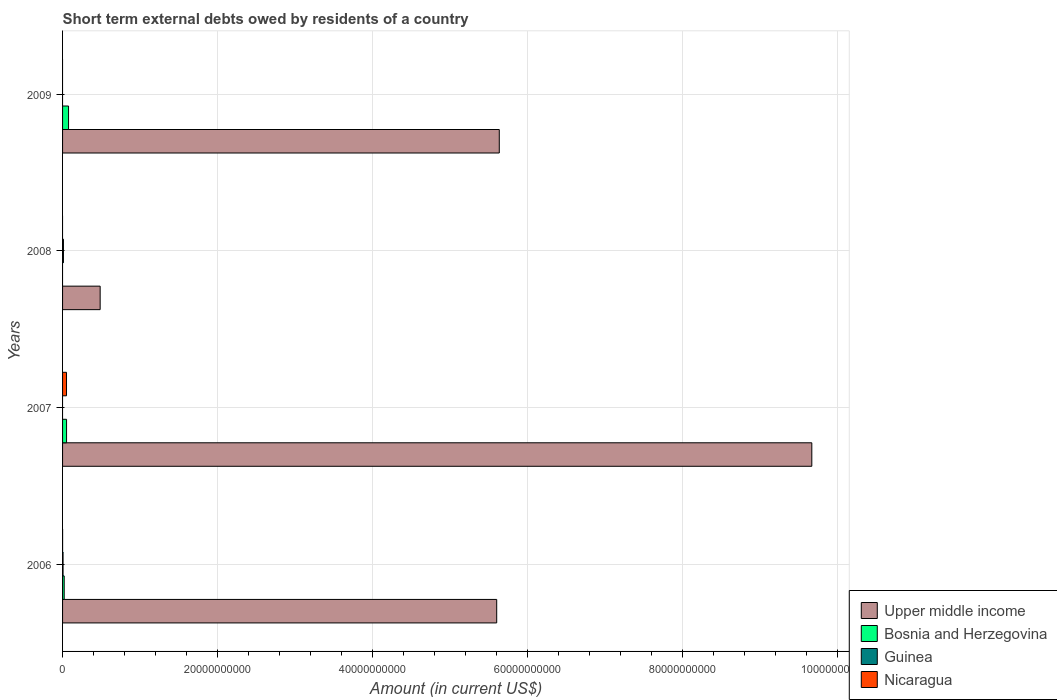How many different coloured bars are there?
Make the answer very short. 4. How many bars are there on the 2nd tick from the bottom?
Provide a short and direct response. 3. In how many cases, is the number of bars for a given year not equal to the number of legend labels?
Offer a very short reply. 3. What is the amount of short-term external debts owed by residents in Upper middle income in 2009?
Offer a terse response. 5.64e+1. Across all years, what is the maximum amount of short-term external debts owed by residents in Guinea?
Keep it short and to the point. 1.12e+08. Across all years, what is the minimum amount of short-term external debts owed by residents in Upper middle income?
Your response must be concise. 4.85e+09. What is the total amount of short-term external debts owed by residents in Nicaragua in the graph?
Make the answer very short. 5.14e+08. What is the difference between the amount of short-term external debts owed by residents in Bosnia and Herzegovina in 2006 and that in 2009?
Your answer should be compact. -5.60e+08. What is the difference between the amount of short-term external debts owed by residents in Bosnia and Herzegovina in 2006 and the amount of short-term external debts owed by residents in Nicaragua in 2008?
Make the answer very short. 2.11e+08. What is the average amount of short-term external debts owed by residents in Upper middle income per year?
Your answer should be compact. 5.35e+1. In the year 2006, what is the difference between the amount of short-term external debts owed by residents in Guinea and amount of short-term external debts owed by residents in Nicaragua?
Keep it short and to the point. 5.90e+07. In how many years, is the amount of short-term external debts owed by residents in Upper middle income greater than 40000000000 US$?
Offer a terse response. 3. What is the ratio of the amount of short-term external debts owed by residents in Upper middle income in 2006 to that in 2008?
Your answer should be compact. 11.55. What is the difference between the highest and the second highest amount of short-term external debts owed by residents in Bosnia and Herzegovina?
Keep it short and to the point. 2.55e+08. What is the difference between the highest and the lowest amount of short-term external debts owed by residents in Guinea?
Give a very brief answer. 1.12e+08. In how many years, is the amount of short-term external debts owed by residents in Nicaragua greater than the average amount of short-term external debts owed by residents in Nicaragua taken over all years?
Give a very brief answer. 1. How many bars are there?
Your response must be concise. 11. Are all the bars in the graph horizontal?
Ensure brevity in your answer.  Yes. How many years are there in the graph?
Your answer should be compact. 4. Where does the legend appear in the graph?
Offer a terse response. Bottom right. How many legend labels are there?
Keep it short and to the point. 4. How are the legend labels stacked?
Provide a short and direct response. Vertical. What is the title of the graph?
Your answer should be compact. Short term external debts owed by residents of a country. What is the label or title of the X-axis?
Give a very brief answer. Amount (in current US$). What is the Amount (in current US$) in Upper middle income in 2006?
Provide a succinct answer. 5.60e+1. What is the Amount (in current US$) in Bosnia and Herzegovina in 2006?
Your response must be concise. 2.11e+08. What is the Amount (in current US$) of Guinea in 2006?
Provide a succinct answer. 6.20e+07. What is the Amount (in current US$) of Upper middle income in 2007?
Keep it short and to the point. 9.67e+1. What is the Amount (in current US$) of Bosnia and Herzegovina in 2007?
Provide a short and direct response. 5.16e+08. What is the Amount (in current US$) in Nicaragua in 2007?
Give a very brief answer. 5.11e+08. What is the Amount (in current US$) of Upper middle income in 2008?
Offer a terse response. 4.85e+09. What is the Amount (in current US$) in Guinea in 2008?
Ensure brevity in your answer.  1.12e+08. What is the Amount (in current US$) of Upper middle income in 2009?
Offer a terse response. 5.64e+1. What is the Amount (in current US$) of Bosnia and Herzegovina in 2009?
Your answer should be compact. 7.71e+08. What is the Amount (in current US$) in Guinea in 2009?
Your answer should be compact. 0. Across all years, what is the maximum Amount (in current US$) of Upper middle income?
Your answer should be compact. 9.67e+1. Across all years, what is the maximum Amount (in current US$) in Bosnia and Herzegovina?
Provide a short and direct response. 7.71e+08. Across all years, what is the maximum Amount (in current US$) of Guinea?
Your response must be concise. 1.12e+08. Across all years, what is the maximum Amount (in current US$) in Nicaragua?
Provide a short and direct response. 5.11e+08. Across all years, what is the minimum Amount (in current US$) in Upper middle income?
Ensure brevity in your answer.  4.85e+09. Across all years, what is the minimum Amount (in current US$) of Bosnia and Herzegovina?
Provide a short and direct response. 0. What is the total Amount (in current US$) of Upper middle income in the graph?
Make the answer very short. 2.14e+11. What is the total Amount (in current US$) of Bosnia and Herzegovina in the graph?
Your answer should be compact. 1.50e+09. What is the total Amount (in current US$) of Guinea in the graph?
Your answer should be very brief. 1.74e+08. What is the total Amount (in current US$) of Nicaragua in the graph?
Provide a succinct answer. 5.14e+08. What is the difference between the Amount (in current US$) of Upper middle income in 2006 and that in 2007?
Provide a short and direct response. -4.07e+1. What is the difference between the Amount (in current US$) in Bosnia and Herzegovina in 2006 and that in 2007?
Offer a terse response. -3.05e+08. What is the difference between the Amount (in current US$) in Nicaragua in 2006 and that in 2007?
Provide a succinct answer. -5.08e+08. What is the difference between the Amount (in current US$) of Upper middle income in 2006 and that in 2008?
Your response must be concise. 5.12e+1. What is the difference between the Amount (in current US$) of Guinea in 2006 and that in 2008?
Keep it short and to the point. -5.00e+07. What is the difference between the Amount (in current US$) of Upper middle income in 2006 and that in 2009?
Ensure brevity in your answer.  -3.34e+08. What is the difference between the Amount (in current US$) in Bosnia and Herzegovina in 2006 and that in 2009?
Offer a terse response. -5.60e+08. What is the difference between the Amount (in current US$) of Upper middle income in 2007 and that in 2008?
Your answer should be very brief. 9.19e+1. What is the difference between the Amount (in current US$) in Upper middle income in 2007 and that in 2009?
Offer a very short reply. 4.03e+1. What is the difference between the Amount (in current US$) in Bosnia and Herzegovina in 2007 and that in 2009?
Your answer should be compact. -2.55e+08. What is the difference between the Amount (in current US$) of Upper middle income in 2008 and that in 2009?
Provide a short and direct response. -5.15e+1. What is the difference between the Amount (in current US$) of Upper middle income in 2006 and the Amount (in current US$) of Bosnia and Herzegovina in 2007?
Your answer should be compact. 5.55e+1. What is the difference between the Amount (in current US$) in Upper middle income in 2006 and the Amount (in current US$) in Nicaragua in 2007?
Make the answer very short. 5.55e+1. What is the difference between the Amount (in current US$) of Bosnia and Herzegovina in 2006 and the Amount (in current US$) of Nicaragua in 2007?
Offer a very short reply. -3.00e+08. What is the difference between the Amount (in current US$) of Guinea in 2006 and the Amount (in current US$) of Nicaragua in 2007?
Keep it short and to the point. -4.49e+08. What is the difference between the Amount (in current US$) in Upper middle income in 2006 and the Amount (in current US$) in Guinea in 2008?
Ensure brevity in your answer.  5.59e+1. What is the difference between the Amount (in current US$) in Bosnia and Herzegovina in 2006 and the Amount (in current US$) in Guinea in 2008?
Make the answer very short. 9.90e+07. What is the difference between the Amount (in current US$) of Upper middle income in 2006 and the Amount (in current US$) of Bosnia and Herzegovina in 2009?
Offer a terse response. 5.53e+1. What is the difference between the Amount (in current US$) in Upper middle income in 2007 and the Amount (in current US$) in Guinea in 2008?
Your response must be concise. 9.66e+1. What is the difference between the Amount (in current US$) in Bosnia and Herzegovina in 2007 and the Amount (in current US$) in Guinea in 2008?
Your answer should be very brief. 4.04e+08. What is the difference between the Amount (in current US$) of Upper middle income in 2007 and the Amount (in current US$) of Bosnia and Herzegovina in 2009?
Provide a succinct answer. 9.59e+1. What is the difference between the Amount (in current US$) in Upper middle income in 2008 and the Amount (in current US$) in Bosnia and Herzegovina in 2009?
Offer a very short reply. 4.08e+09. What is the average Amount (in current US$) in Upper middle income per year?
Your answer should be very brief. 5.35e+1. What is the average Amount (in current US$) of Bosnia and Herzegovina per year?
Provide a succinct answer. 3.74e+08. What is the average Amount (in current US$) of Guinea per year?
Offer a terse response. 4.35e+07. What is the average Amount (in current US$) of Nicaragua per year?
Keep it short and to the point. 1.28e+08. In the year 2006, what is the difference between the Amount (in current US$) in Upper middle income and Amount (in current US$) in Bosnia and Herzegovina?
Offer a terse response. 5.58e+1. In the year 2006, what is the difference between the Amount (in current US$) in Upper middle income and Amount (in current US$) in Guinea?
Your answer should be compact. 5.60e+1. In the year 2006, what is the difference between the Amount (in current US$) of Upper middle income and Amount (in current US$) of Nicaragua?
Offer a very short reply. 5.60e+1. In the year 2006, what is the difference between the Amount (in current US$) in Bosnia and Herzegovina and Amount (in current US$) in Guinea?
Your answer should be very brief. 1.49e+08. In the year 2006, what is the difference between the Amount (in current US$) in Bosnia and Herzegovina and Amount (in current US$) in Nicaragua?
Offer a terse response. 2.08e+08. In the year 2006, what is the difference between the Amount (in current US$) of Guinea and Amount (in current US$) of Nicaragua?
Make the answer very short. 5.90e+07. In the year 2007, what is the difference between the Amount (in current US$) in Upper middle income and Amount (in current US$) in Bosnia and Herzegovina?
Your answer should be compact. 9.62e+1. In the year 2007, what is the difference between the Amount (in current US$) of Upper middle income and Amount (in current US$) of Nicaragua?
Provide a succinct answer. 9.62e+1. In the year 2007, what is the difference between the Amount (in current US$) in Bosnia and Herzegovina and Amount (in current US$) in Nicaragua?
Provide a short and direct response. 5.44e+06. In the year 2008, what is the difference between the Amount (in current US$) in Upper middle income and Amount (in current US$) in Guinea?
Your answer should be very brief. 4.74e+09. In the year 2009, what is the difference between the Amount (in current US$) in Upper middle income and Amount (in current US$) in Bosnia and Herzegovina?
Give a very brief answer. 5.56e+1. What is the ratio of the Amount (in current US$) of Upper middle income in 2006 to that in 2007?
Offer a terse response. 0.58. What is the ratio of the Amount (in current US$) of Bosnia and Herzegovina in 2006 to that in 2007?
Offer a terse response. 0.41. What is the ratio of the Amount (in current US$) in Nicaragua in 2006 to that in 2007?
Ensure brevity in your answer.  0.01. What is the ratio of the Amount (in current US$) of Upper middle income in 2006 to that in 2008?
Your response must be concise. 11.55. What is the ratio of the Amount (in current US$) of Guinea in 2006 to that in 2008?
Your answer should be very brief. 0.55. What is the ratio of the Amount (in current US$) of Bosnia and Herzegovina in 2006 to that in 2009?
Your answer should be compact. 0.27. What is the ratio of the Amount (in current US$) in Upper middle income in 2007 to that in 2008?
Offer a very short reply. 19.93. What is the ratio of the Amount (in current US$) in Upper middle income in 2007 to that in 2009?
Your answer should be very brief. 1.72. What is the ratio of the Amount (in current US$) of Bosnia and Herzegovina in 2007 to that in 2009?
Keep it short and to the point. 0.67. What is the ratio of the Amount (in current US$) in Upper middle income in 2008 to that in 2009?
Provide a succinct answer. 0.09. What is the difference between the highest and the second highest Amount (in current US$) in Upper middle income?
Your answer should be compact. 4.03e+1. What is the difference between the highest and the second highest Amount (in current US$) in Bosnia and Herzegovina?
Provide a short and direct response. 2.55e+08. What is the difference between the highest and the lowest Amount (in current US$) of Upper middle income?
Give a very brief answer. 9.19e+1. What is the difference between the highest and the lowest Amount (in current US$) in Bosnia and Herzegovina?
Offer a very short reply. 7.71e+08. What is the difference between the highest and the lowest Amount (in current US$) in Guinea?
Your answer should be very brief. 1.12e+08. What is the difference between the highest and the lowest Amount (in current US$) in Nicaragua?
Give a very brief answer. 5.11e+08. 